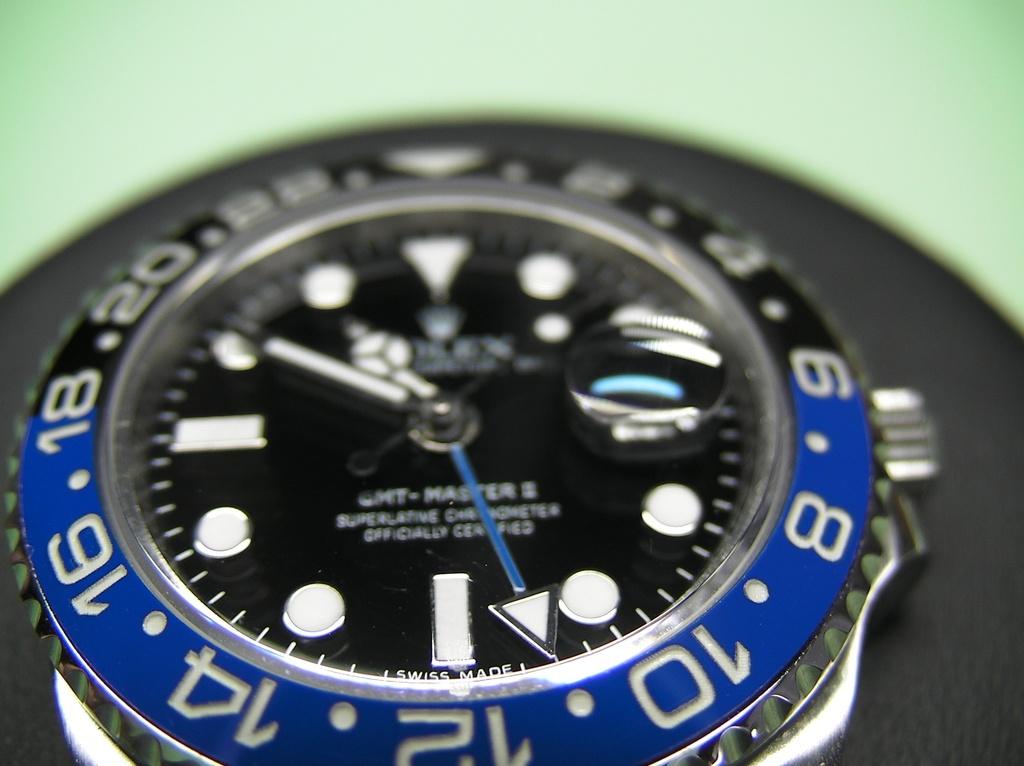What brand of watch is this?
Make the answer very short. Rolex. What nationality made this watch?
Offer a terse response. Swiss. 